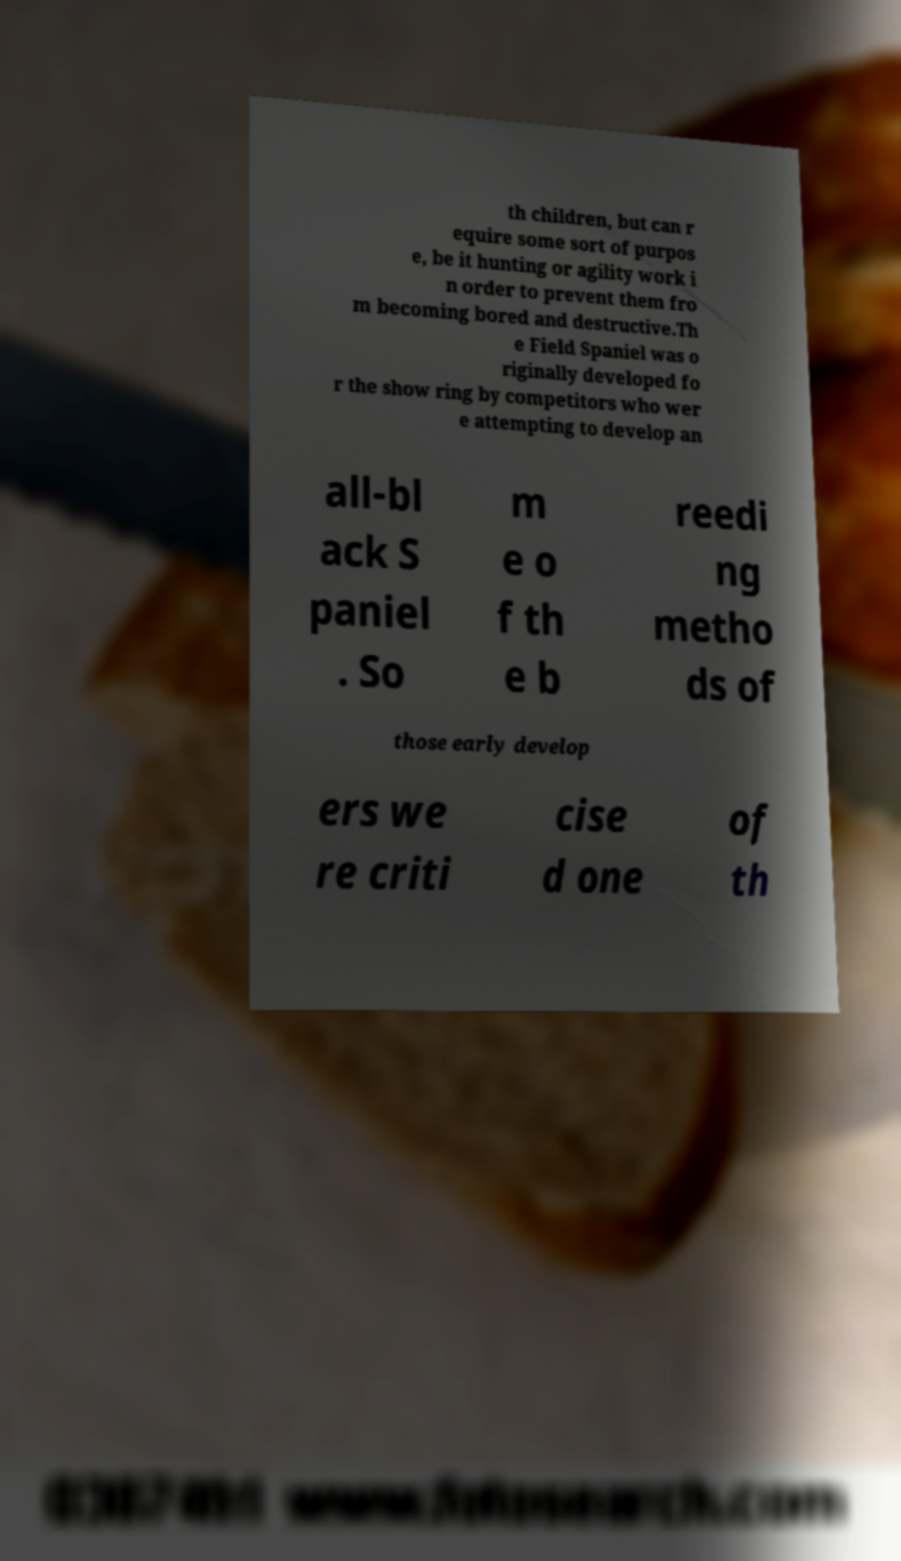Could you assist in decoding the text presented in this image and type it out clearly? th children, but can r equire some sort of purpos e, be it hunting or agility work i n order to prevent them fro m becoming bored and destructive.Th e Field Spaniel was o riginally developed fo r the show ring by competitors who wer e attempting to develop an all-bl ack S paniel . So m e o f th e b reedi ng metho ds of those early develop ers we re criti cise d one of th 